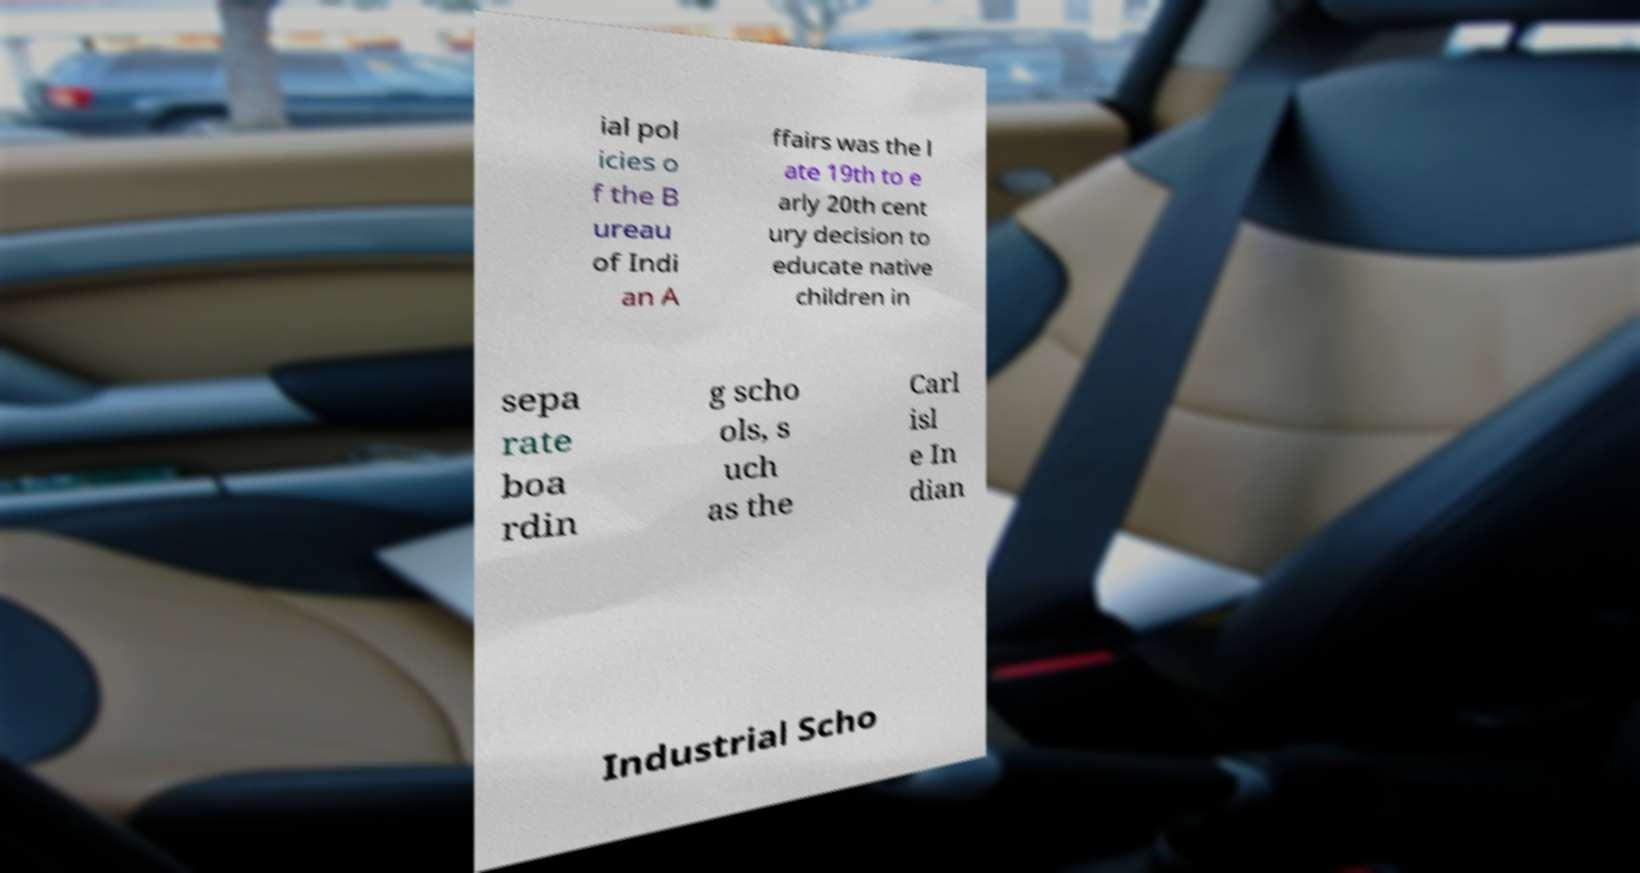Please identify and transcribe the text found in this image. ial pol icies o f the B ureau of Indi an A ffairs was the l ate 19th to e arly 20th cent ury decision to educate native children in sepa rate boa rdin g scho ols, s uch as the Carl isl e In dian Industrial Scho 